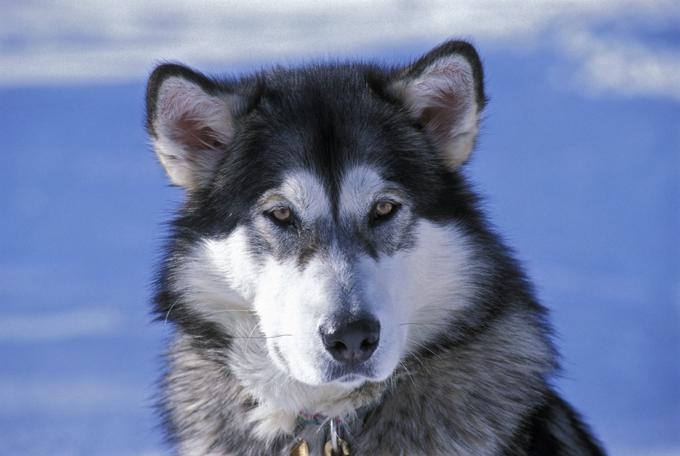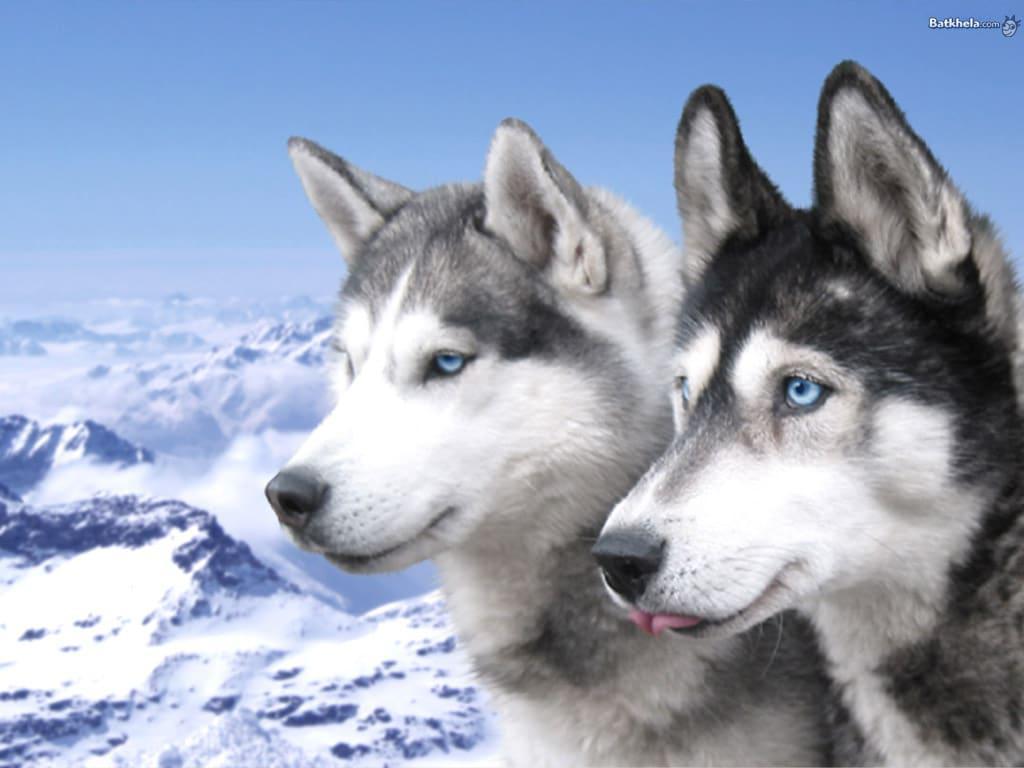The first image is the image on the left, the second image is the image on the right. Evaluate the accuracy of this statement regarding the images: "The left and right image contains a total of three dogs with at least two in the snow.". Is it true? Answer yes or no. Yes. The first image is the image on the left, the second image is the image on the right. Given the left and right images, does the statement "The right image contains one dog, who is looking at the camera with a smiling face and his tongue hanging down past his chin." hold true? Answer yes or no. No. 